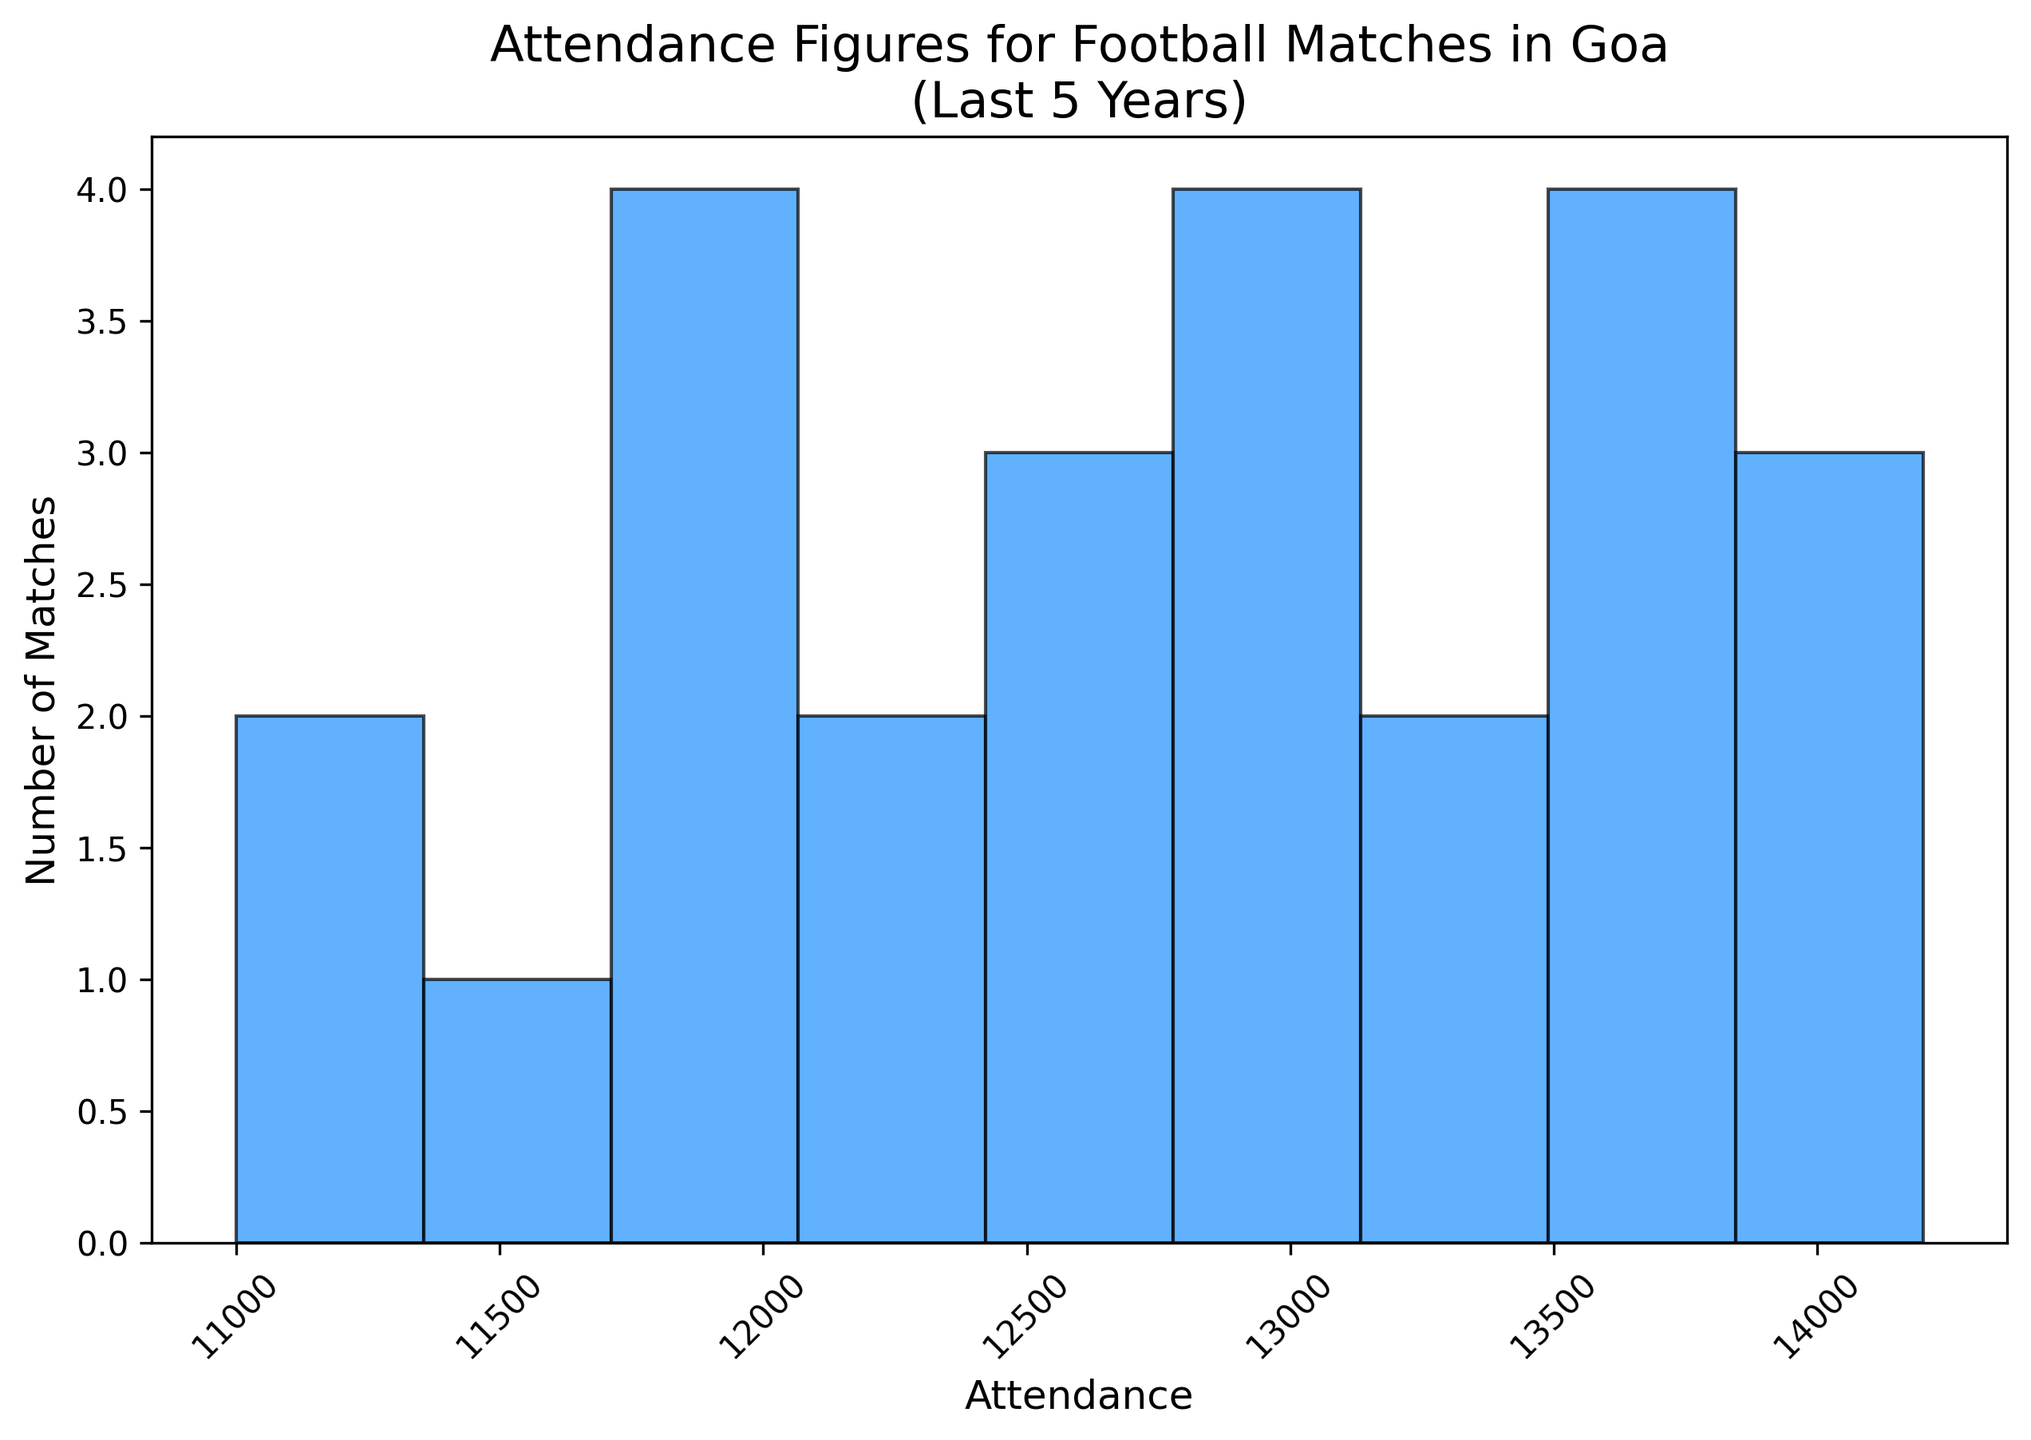When were the highest attendance figures recorded among the last five years? To determine the year with the highest attendance figures, we need to look at the peak attendance values for each year. The year 2022 has the highest values above 13,500, followed closely by 2023.
Answer: 2022 What is the range of the attendance figures for all matches over the last five years? The range can be calculated by finding the minimum and maximum attendances from the data. The smallest attendance is 11,000 and the largest is 14,200. Hence, the range is 14,200 - 11,000.
Answer: 3,200 How does the number of matches with attendance between 12,000 and 13,000 compare to those between 13,000 and 14,000? To answer this, we compare the counts in specified bins. From the histogram, the count of matches with 12,000 to 13,000 attendance appears lower than those between 13,000 to 14,000.
Answer: Fewer Which attendance bin has the highest frequency of matches? The bin with the highest bar in the histogram indicates the range with the most matches. Observing the histogram, the bin between 13,000 and 14,000 has the highest number of matches.
Answer: 13,000-14,000 What is the median attendance figure based on the histogram? To find the median, we list all attendances (at least 25 data points) in an ascending order and find the middle value. With even entries, the median is the average of the 12th and 13th values. Here, it’s approximately 13,000.
Answer: ~13,000 How many matches recorded attendance figures below 12,000? By examining the histogram bars that span attendance figures below 12,000, we can count the number of matches in these bins. The data shows three matches in this category.
Answer: Three matches 